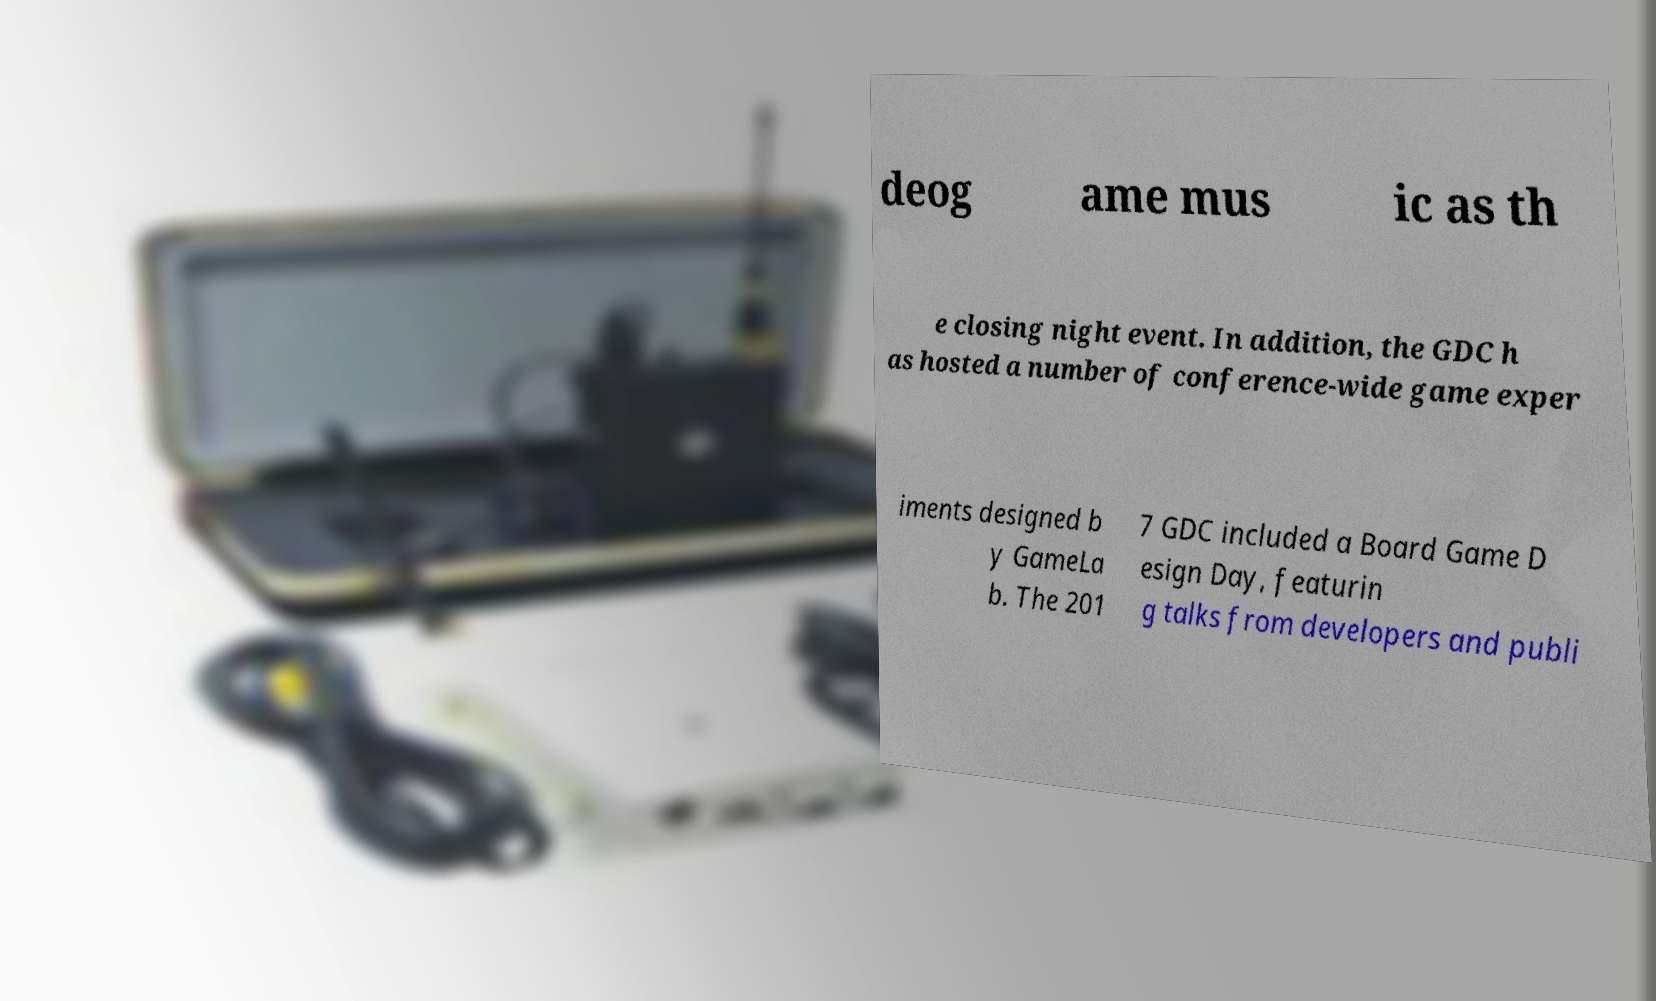Can you read and provide the text displayed in the image?This photo seems to have some interesting text. Can you extract and type it out for me? deog ame mus ic as th e closing night event. In addition, the GDC h as hosted a number of conference-wide game exper iments designed b y GameLa b. The 201 7 GDC included a Board Game D esign Day, featurin g talks from developers and publi 